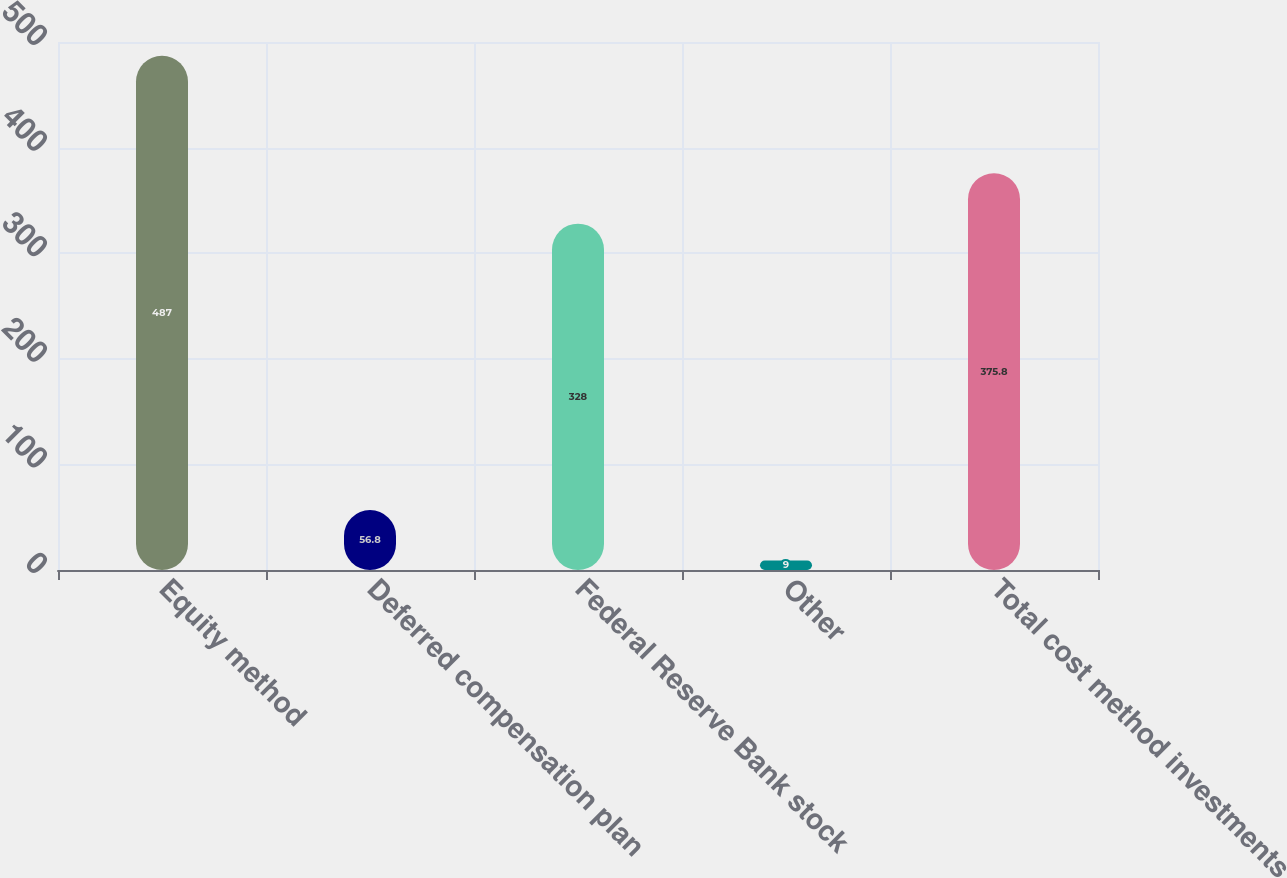<chart> <loc_0><loc_0><loc_500><loc_500><bar_chart><fcel>Equity method<fcel>Deferred compensation plan<fcel>Federal Reserve Bank stock<fcel>Other<fcel>Total cost method investments<nl><fcel>487<fcel>56.8<fcel>328<fcel>9<fcel>375.8<nl></chart> 